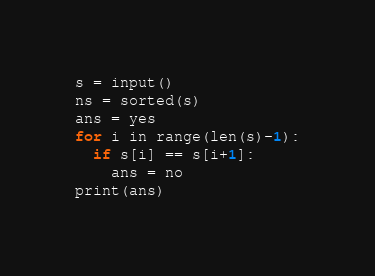Convert code to text. <code><loc_0><loc_0><loc_500><loc_500><_Python_>s = input()
ns = sorted(s)
ans = yes
for i in range(len(s)-1):
  if s[i] == s[i+1]:
    ans = no
print(ans)</code> 